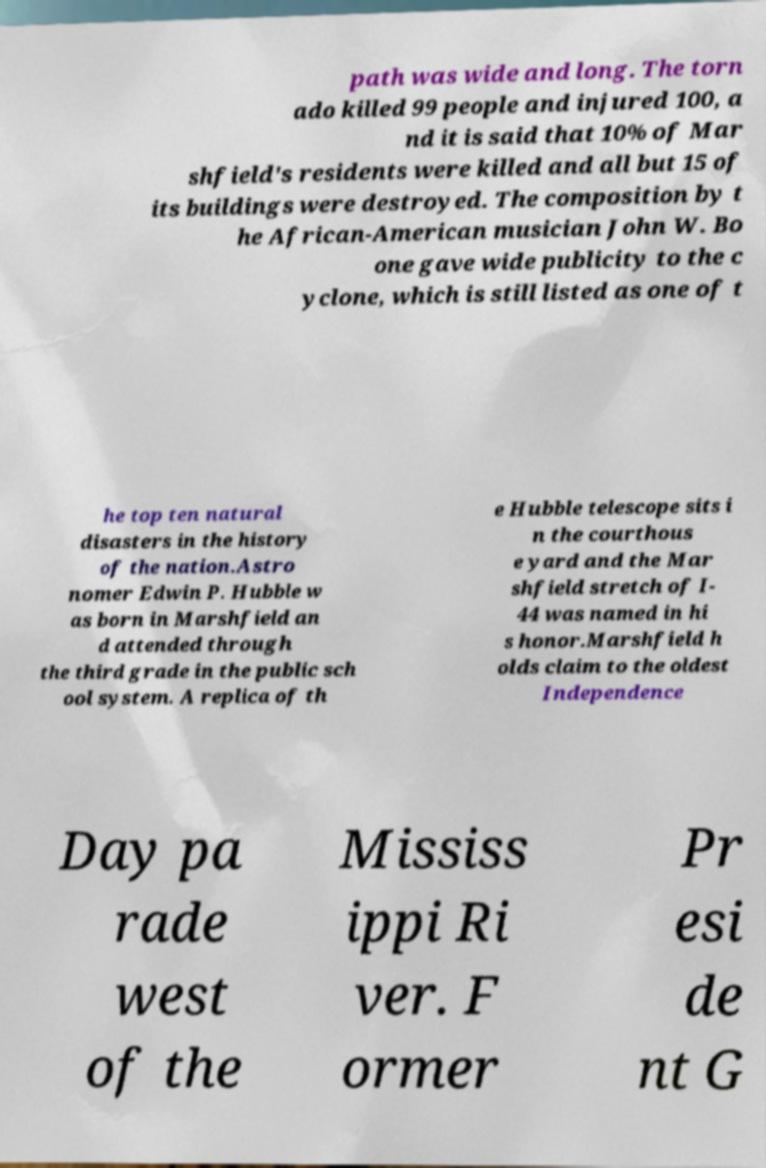Please identify and transcribe the text found in this image. path was wide and long. The torn ado killed 99 people and injured 100, a nd it is said that 10% of Mar shfield's residents were killed and all but 15 of its buildings were destroyed. The composition by t he African-American musician John W. Bo one gave wide publicity to the c yclone, which is still listed as one of t he top ten natural disasters in the history of the nation.Astro nomer Edwin P. Hubble w as born in Marshfield an d attended through the third grade in the public sch ool system. A replica of th e Hubble telescope sits i n the courthous e yard and the Mar shfield stretch of I- 44 was named in hi s honor.Marshfield h olds claim to the oldest Independence Day pa rade west of the Mississ ippi Ri ver. F ormer Pr esi de nt G 